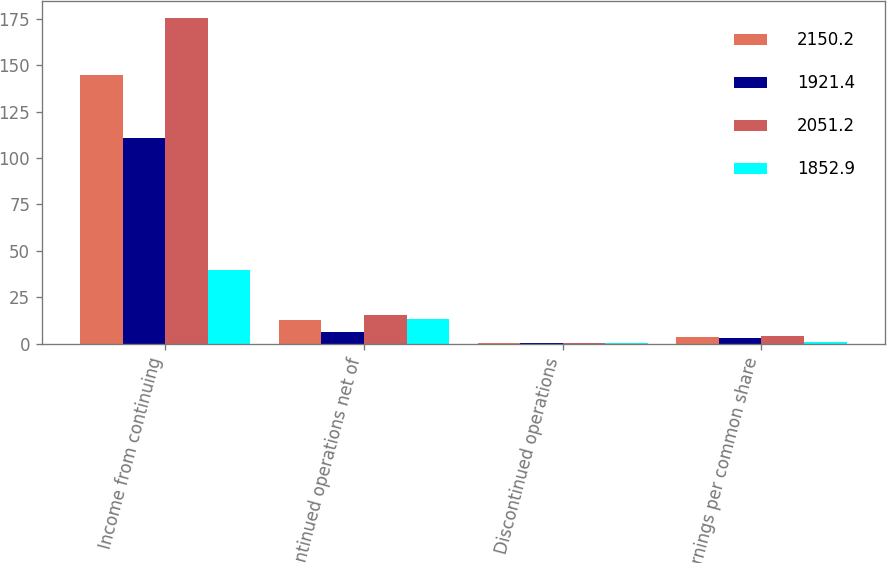Convert chart to OTSL. <chart><loc_0><loc_0><loc_500><loc_500><stacked_bar_chart><ecel><fcel>Income from continuing<fcel>Discontinued operations net of<fcel>Discontinued operations<fcel>Net earnings per common share<nl><fcel>2150.2<fcel>144.8<fcel>12.8<fcel>0.33<fcel>3.45<nl><fcel>1921.4<fcel>111<fcel>6.1<fcel>0.16<fcel>3.1<nl><fcel>2051.2<fcel>175.6<fcel>15.4<fcel>0.42<fcel>4.43<nl><fcel>1852.9<fcel>39.8<fcel>13.3<fcel>0.38<fcel>0.75<nl></chart> 